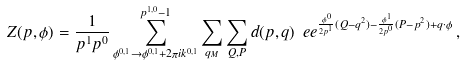Convert formula to latex. <formula><loc_0><loc_0><loc_500><loc_500>Z ( p , \phi ) = \frac { 1 } { p ^ { 1 } p ^ { 0 } } \sum _ { \phi ^ { 0 , 1 } \rightarrow \phi ^ { 0 , 1 } + 2 \pi i k ^ { 0 , 1 } } ^ { p ^ { 1 , 0 } - 1 } \sum _ { q _ { M } } \sum _ { Q , P } d ( p , q ) \ e e ^ { \frac { \phi ^ { 0 } } { 2 p ^ { 1 } } ( Q - q ^ { 2 } ) - \frac { \phi ^ { 1 } } { 2 p ^ { 0 } } ( P - p ^ { 2 } ) + q \cdot \phi } \, ,</formula> 